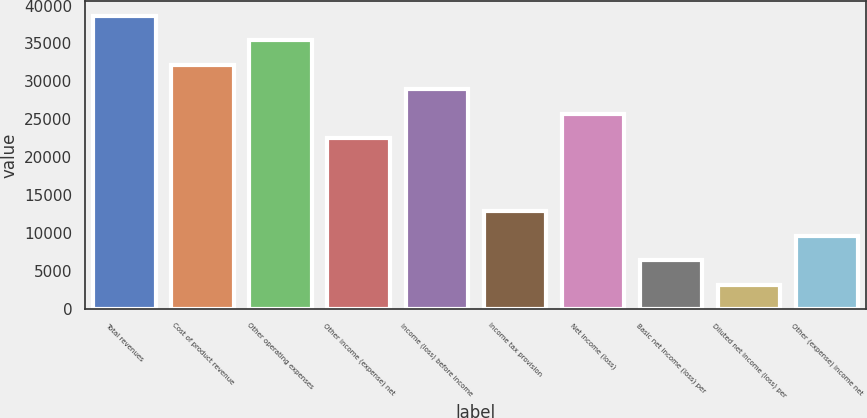<chart> <loc_0><loc_0><loc_500><loc_500><bar_chart><fcel>Total revenues<fcel>Cost of product revenue<fcel>Other operating expenses<fcel>Other income (expense) net<fcel>Income (loss) before income<fcel>Income tax provision<fcel>Net income (loss)<fcel>Basic net income (loss) per<fcel>Diluted net income (loss) per<fcel>Other (expense) income net<nl><fcel>38637.6<fcel>32198<fcel>35417.8<fcel>22538.6<fcel>28978.2<fcel>12879.2<fcel>25758.4<fcel>6439.62<fcel>3219.82<fcel>9659.42<nl></chart> 